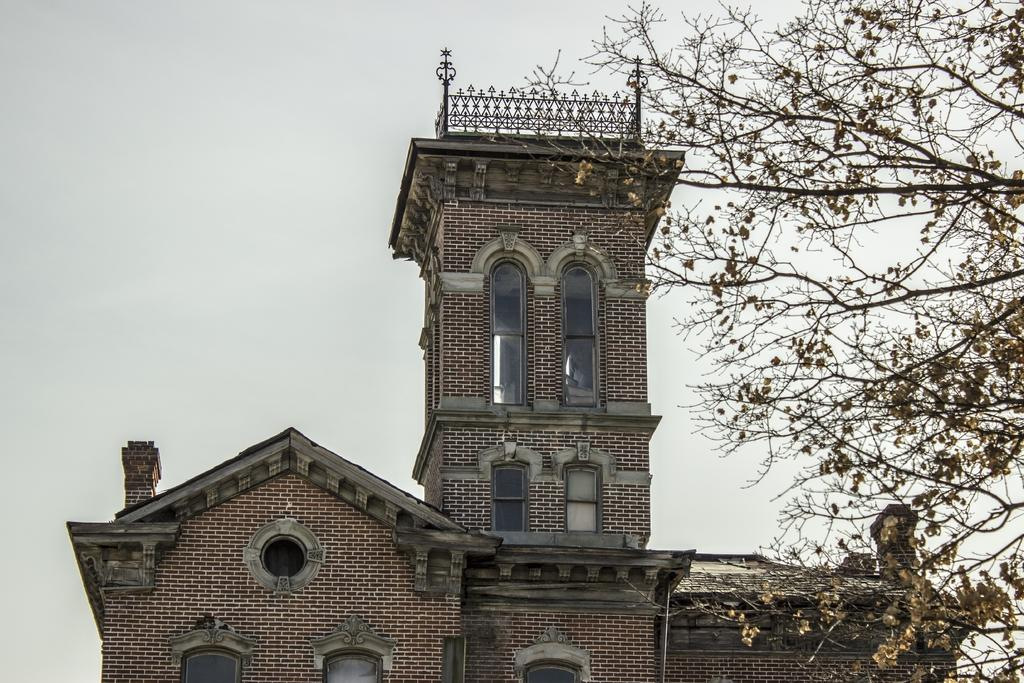What type of building is visible in the image? There is a building with glass windows in the image. What can be seen on the right side of the image? There is a tree on the right side of the image. What is visible in the background of the image? The sky is visible in the background of the image. What type of band is performing in the image? There is no band present in the image; it only features a building, a tree, and the sky. 